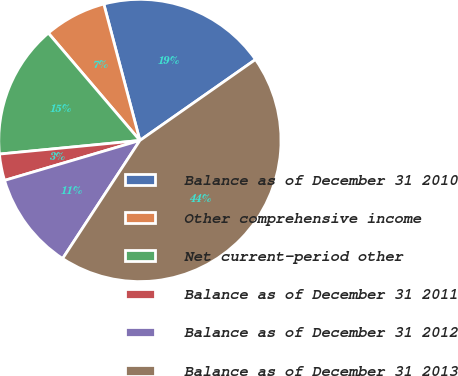Convert chart. <chart><loc_0><loc_0><loc_500><loc_500><pie_chart><fcel>Balance as of December 31 2010<fcel>Other comprehensive income<fcel>Net current-period other<fcel>Balance as of December 31 2011<fcel>Balance as of December 31 2012<fcel>Balance as of December 31 2013<nl><fcel>19.39%<fcel>7.12%<fcel>15.3%<fcel>3.03%<fcel>11.21%<fcel>43.94%<nl></chart> 